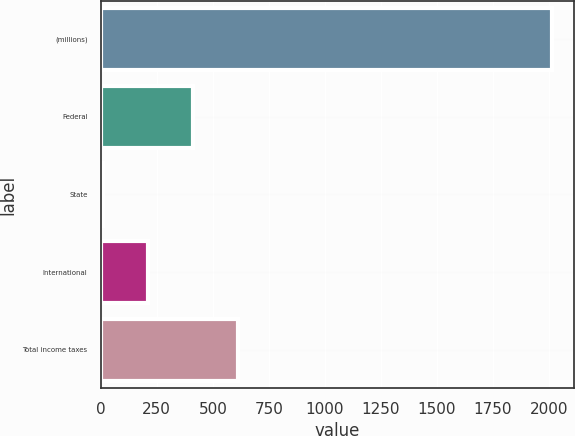<chart> <loc_0><loc_0><loc_500><loc_500><bar_chart><fcel>(millions)<fcel>Federal<fcel>State<fcel>International<fcel>Total income taxes<nl><fcel>2013<fcel>410.84<fcel>10.3<fcel>210.57<fcel>611.11<nl></chart> 